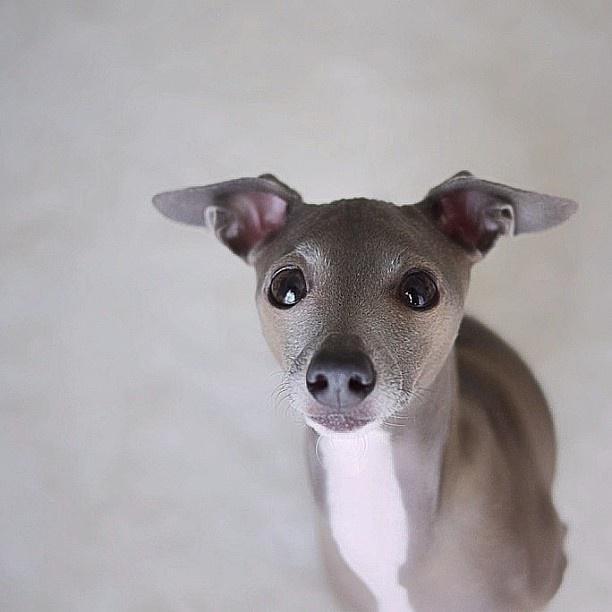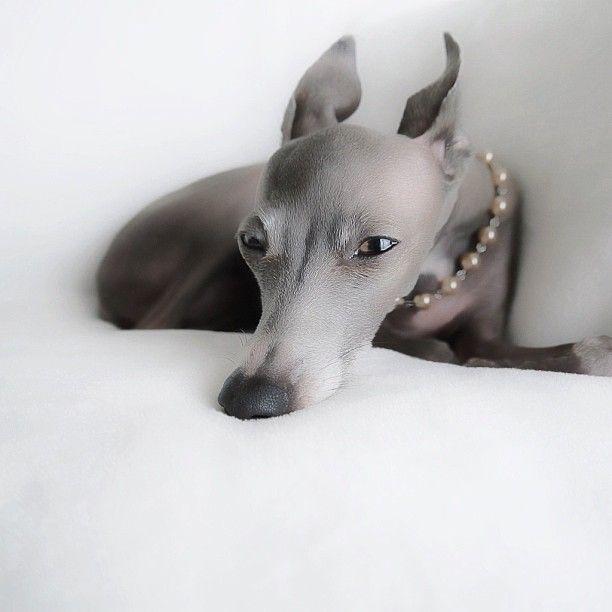The first image is the image on the left, the second image is the image on the right. Given the left and right images, does the statement "An image shows a hound wearing a pearl-look necklace." hold true? Answer yes or no. Yes. The first image is the image on the left, the second image is the image on the right. Evaluate the accuracy of this statement regarding the images: "A dog with a necklace is lying down in one of the images.". Is it true? Answer yes or no. Yes. 